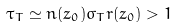<formula> <loc_0><loc_0><loc_500><loc_500>\tau _ { T } \simeq n ( z _ { 0 } ) \sigma _ { T } r ( z _ { 0 } ) > 1</formula> 